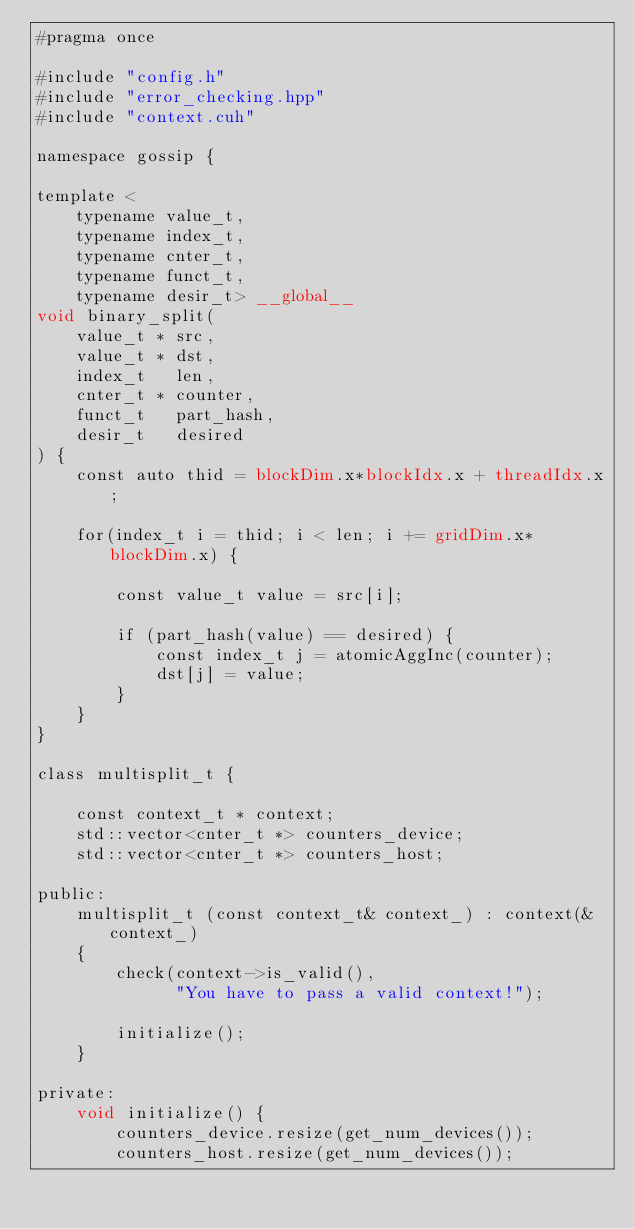Convert code to text. <code><loc_0><loc_0><loc_500><loc_500><_Cuda_>#pragma once

#include "config.h"
#include "error_checking.hpp"
#include "context.cuh"

namespace gossip {

template <
    typename value_t,
    typename index_t,
    typename cnter_t,
    typename funct_t,
    typename desir_t> __global__
void binary_split(
    value_t * src,
    value_t * dst,
    index_t   len,
    cnter_t * counter,
    funct_t   part_hash,
    desir_t   desired
) {
    const auto thid = blockDim.x*blockIdx.x + threadIdx.x;

    for(index_t i = thid; i < len; i += gridDim.x*blockDim.x) {

        const value_t value = src[i];

        if (part_hash(value) == desired) {
            const index_t j = atomicAggInc(counter);
            dst[j] = value;
        }
    }
}

class multisplit_t {

    const context_t * context;
    std::vector<cnter_t *> counters_device;
    std::vector<cnter_t *> counters_host;

public:
    multisplit_t (const context_t& context_) : context(&context_)
    {
        check(context->is_valid(),
              "You have to pass a valid context!");

        initialize();
    }

private:
    void initialize() {
        counters_device.resize(get_num_devices());
        counters_host.resize(get_num_devices());
</code> 